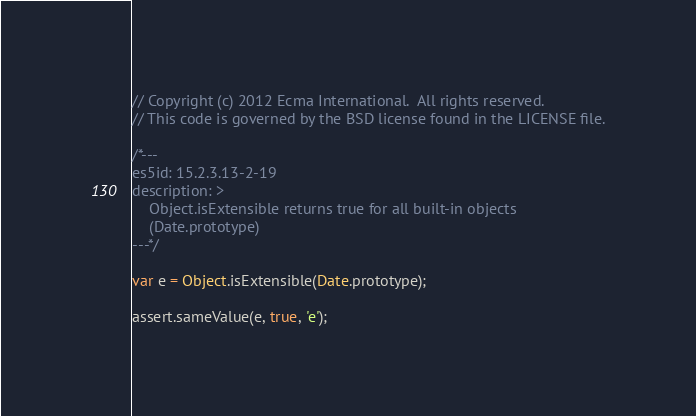<code> <loc_0><loc_0><loc_500><loc_500><_JavaScript_>// Copyright (c) 2012 Ecma International.  All rights reserved.
// This code is governed by the BSD license found in the LICENSE file.

/*---
es5id: 15.2.3.13-2-19
description: >
    Object.isExtensible returns true for all built-in objects
    (Date.prototype)
---*/

var e = Object.isExtensible(Date.prototype);

assert.sameValue(e, true, 'e');
</code> 